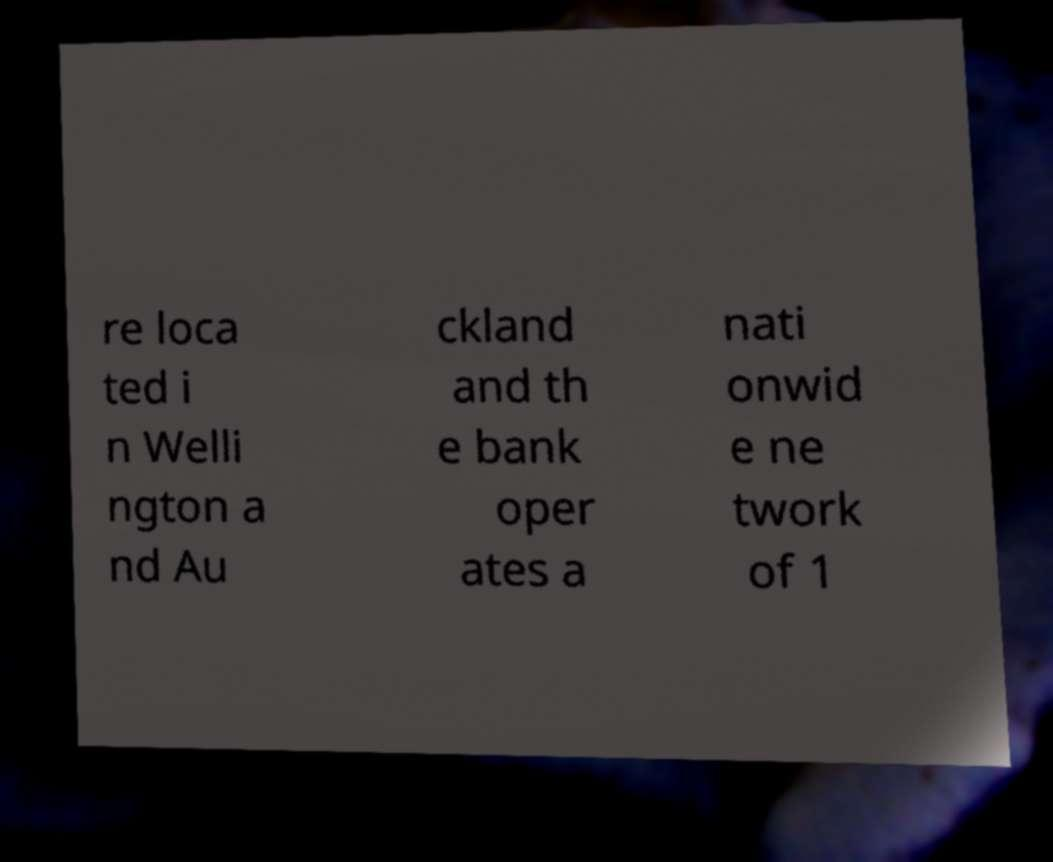Can you accurately transcribe the text from the provided image for me? re loca ted i n Welli ngton a nd Au ckland and th e bank oper ates a nati onwid e ne twork of 1 